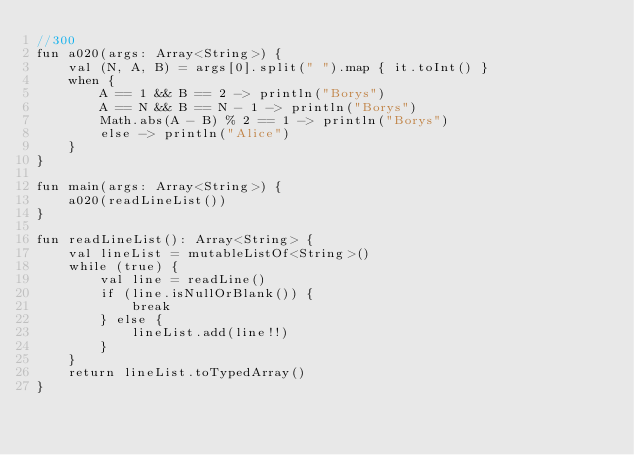<code> <loc_0><loc_0><loc_500><loc_500><_Kotlin_>//300
fun a020(args: Array<String>) {
    val (N, A, B) = args[0].split(" ").map { it.toInt() }
    when {
        A == 1 && B == 2 -> println("Borys")
        A == N && B == N - 1 -> println("Borys")
        Math.abs(A - B) % 2 == 1 -> println("Borys")
        else -> println("Alice")
    }
}

fun main(args: Array<String>) {
    a020(readLineList())
}

fun readLineList(): Array<String> {
    val lineList = mutableListOf<String>()
    while (true) {
        val line = readLine()
        if (line.isNullOrBlank()) {
            break
        } else {
            lineList.add(line!!)
        }
    }
    return lineList.toTypedArray()
}</code> 